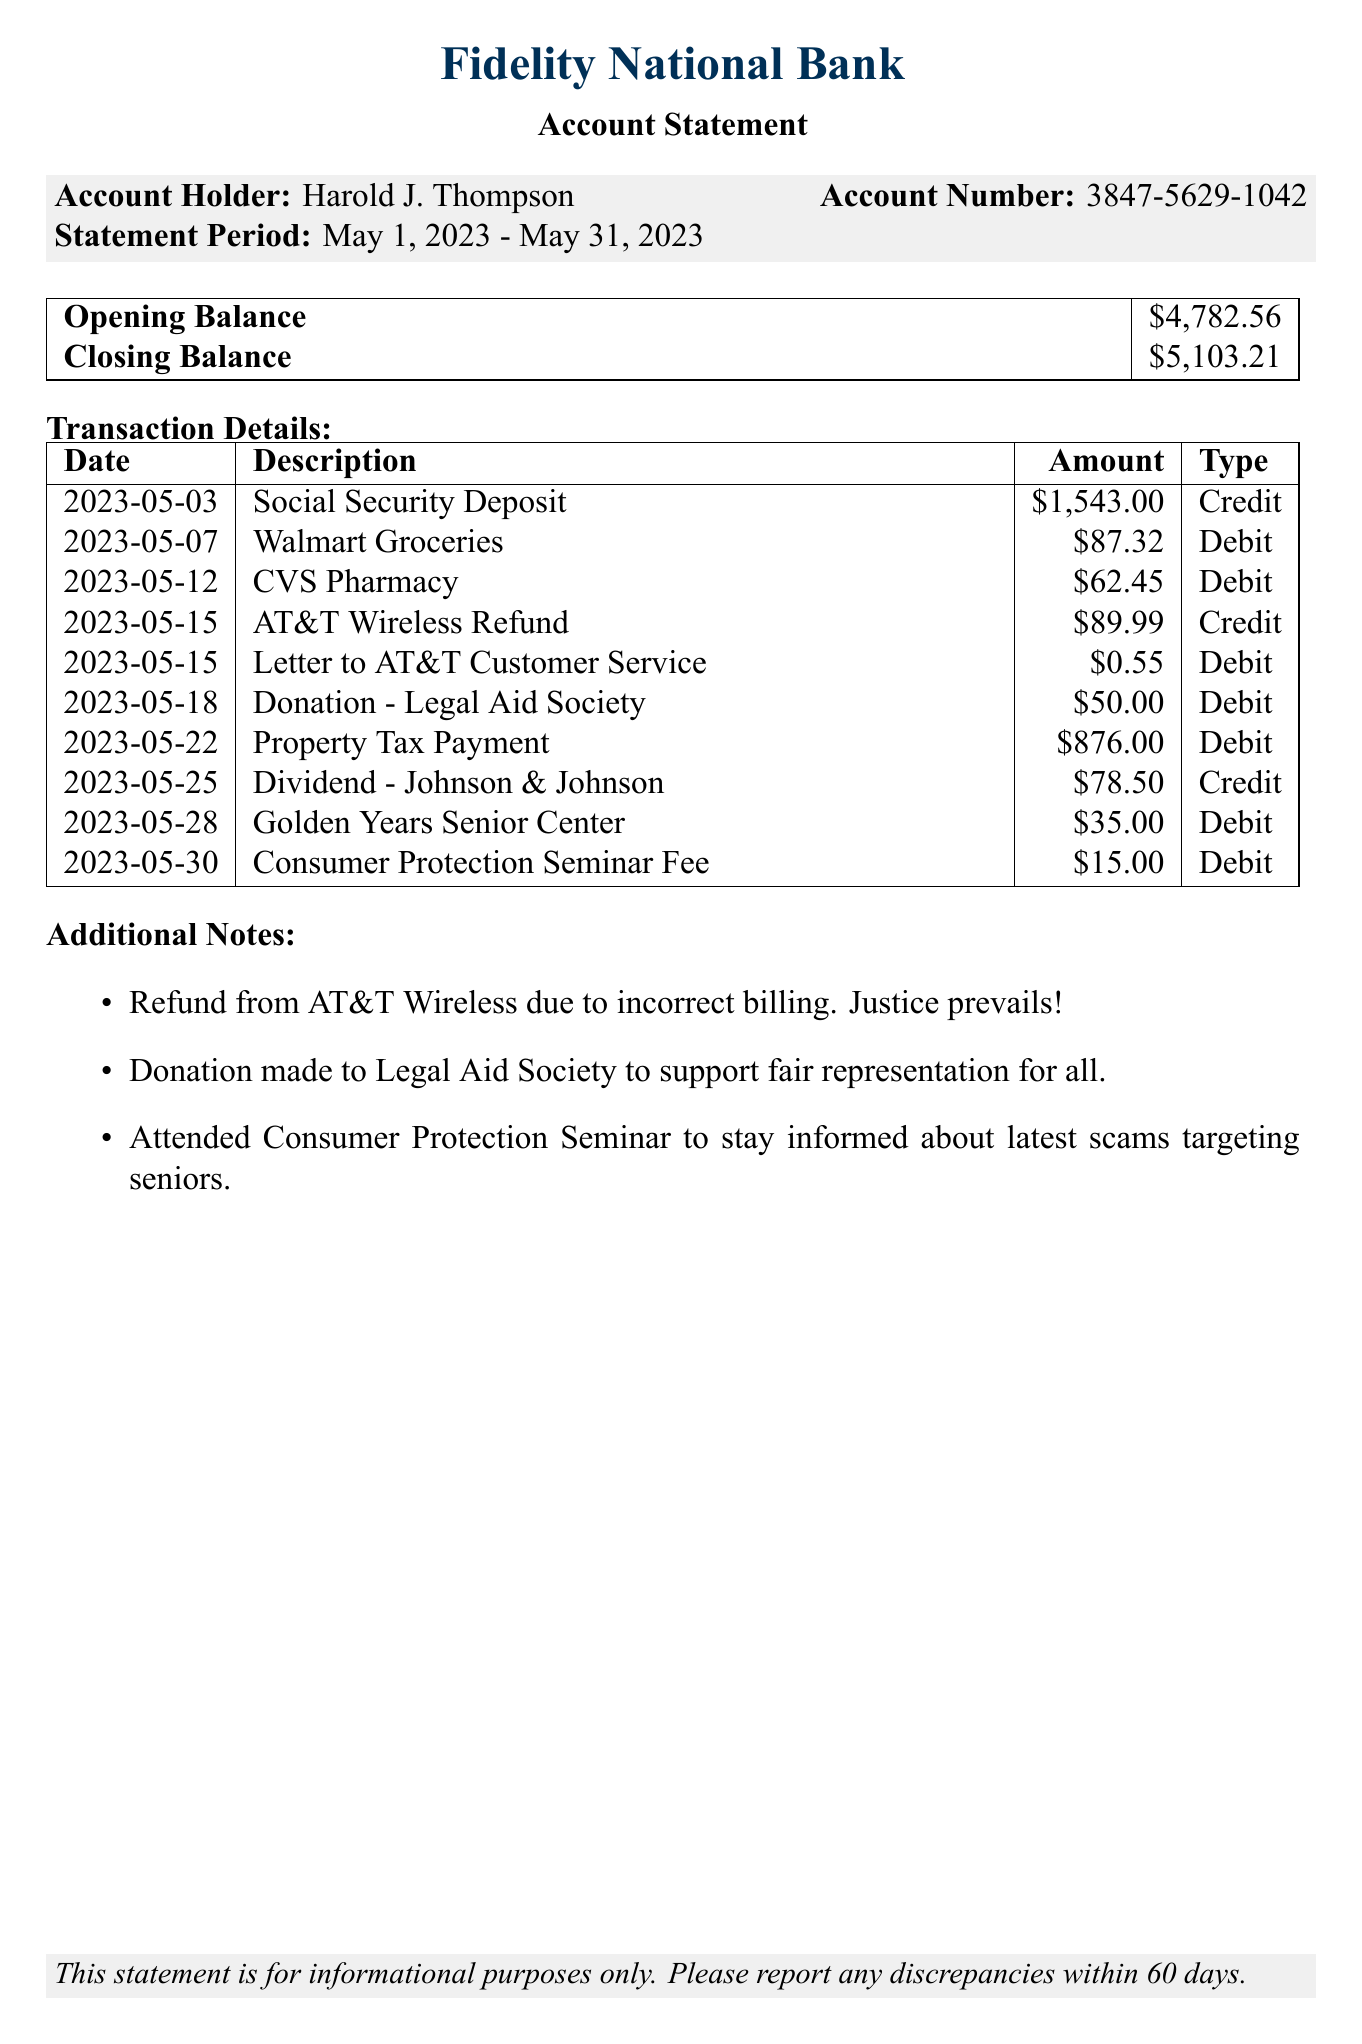What is the account holder's name? The account holder's name is listed prominently at the top of the document.
Answer: Harold J. Thompson What is the account number? The account number is shown in the account information section of the document.
Answer: 3847-5629-1042 What is the closing balance? The closing balance is found in the summary of account balances section of the document.
Answer: $5,103.21 How much was refunded from AT&T Wireless? The refund amount from AT&T Wireless is detailed in the transaction list.
Answer: $89.99 What date was the Social Security deposit made? The date for the Social Security deposit is provided in the transaction details table.
Answer: 2023-05-03 What donation is mentioned in the additional notes? The donation mentioned in the additional notes relates to the organization that received it.
Answer: Legal Aid Society How many debit transactions are listed? The count of debit transactions can be obtained by reviewing the transaction details section.
Answer: Five What is one of the purposes mentioned for attending the seminar? The purpose for attending the seminar is indicated in the additional notes.
Answer: To stay informed about latest scams targeting seniors 